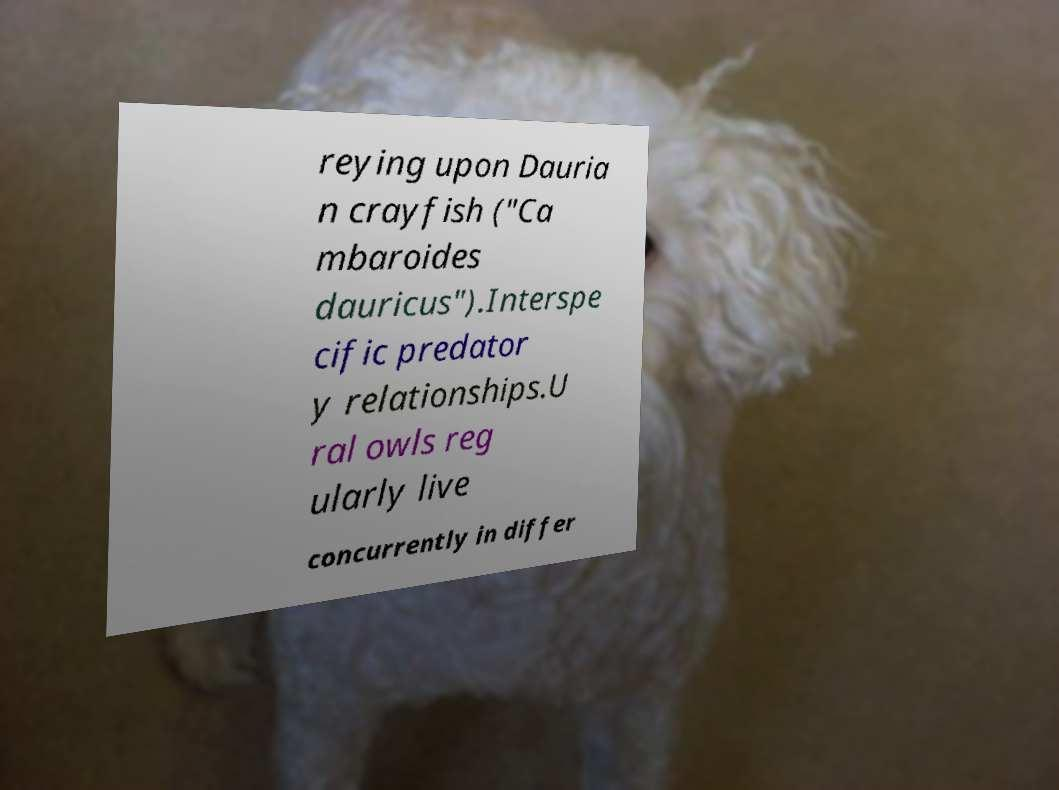Could you extract and type out the text from this image? reying upon Dauria n crayfish ("Ca mbaroides dauricus").Interspe cific predator y relationships.U ral owls reg ularly live concurrently in differ 